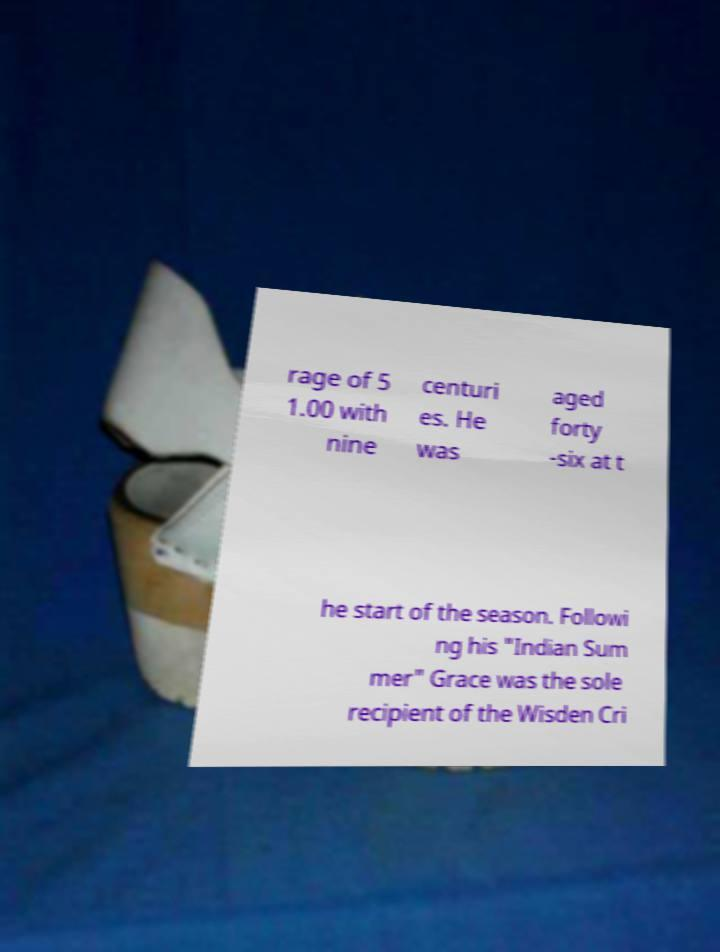Can you read and provide the text displayed in the image?This photo seems to have some interesting text. Can you extract and type it out for me? rage of 5 1.00 with nine centuri es. He was aged forty -six at t he start of the season. Followi ng his "Indian Sum mer" Grace was the sole recipient of the Wisden Cri 